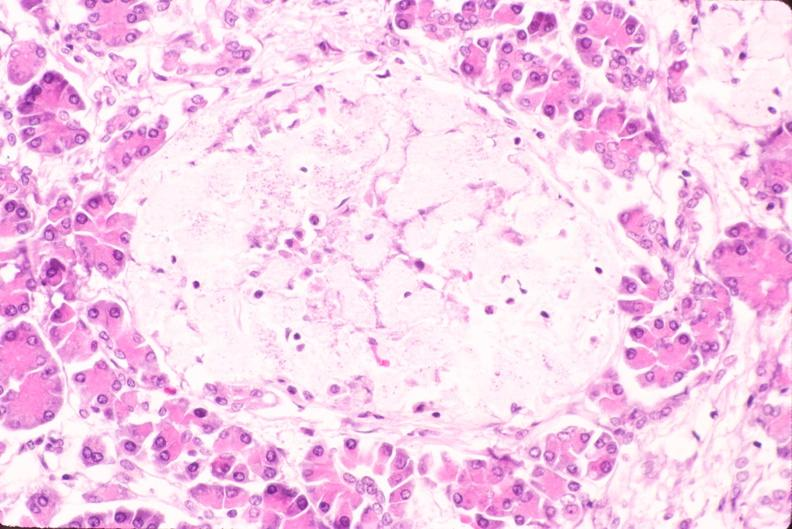s endocrine present?
Answer the question using a single word or phrase. Yes 